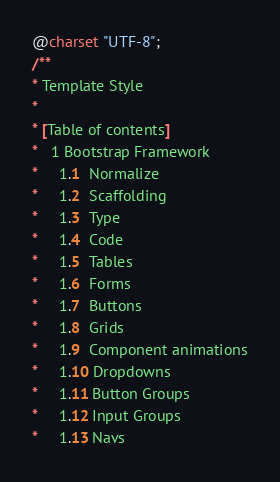Convert code to text. <code><loc_0><loc_0><loc_500><loc_500><_CSS_>@charset "UTF-8";
/**
* Template Style
*
* [Table of contents]
*   1 Bootstrap Framework
*     1.1  Normalize
*     1.2  Scaffolding
*     1.3  Type
*     1.4  Code
*     1.5  Tables
*     1.6  Forms
*     1.7  Buttons
*     1.8  Grids
*     1.9  Component animations
*     1.10 Dropdowns
*     1.11 Button Groups
*     1.12 Input Groups
*     1.13 Navs</code> 